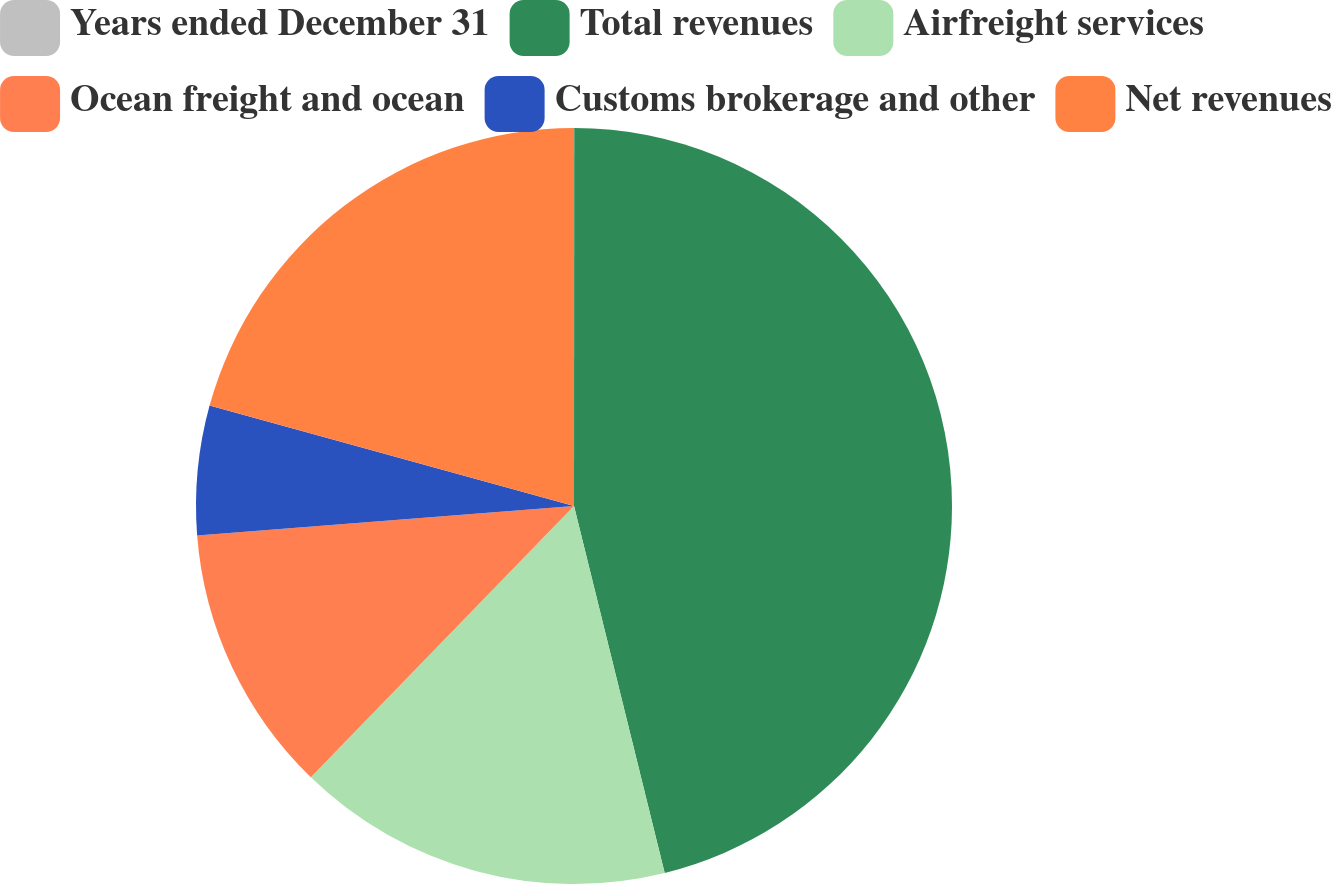<chart> <loc_0><loc_0><loc_500><loc_500><pie_chart><fcel>Years ended December 31<fcel>Total revenues<fcel>Airfreight services<fcel>Ocean freight and ocean<fcel>Customs brokerage and other<fcel>Net revenues<nl><fcel>0.01%<fcel>46.13%<fcel>16.11%<fcel>11.5%<fcel>5.52%<fcel>20.72%<nl></chart> 